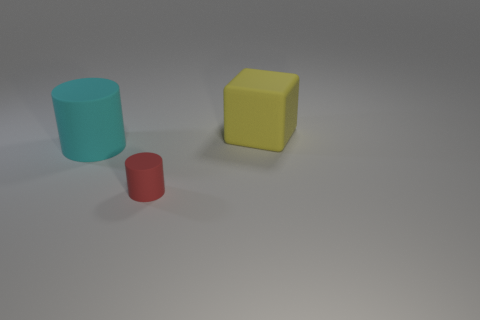Add 2 small matte things. How many objects exist? 5 Subtract all cubes. How many objects are left? 2 Subtract all large rubber blocks. Subtract all purple metallic spheres. How many objects are left? 2 Add 1 red rubber cylinders. How many red rubber cylinders are left? 2 Add 2 tiny red objects. How many tiny red objects exist? 3 Subtract 0 green cylinders. How many objects are left? 3 